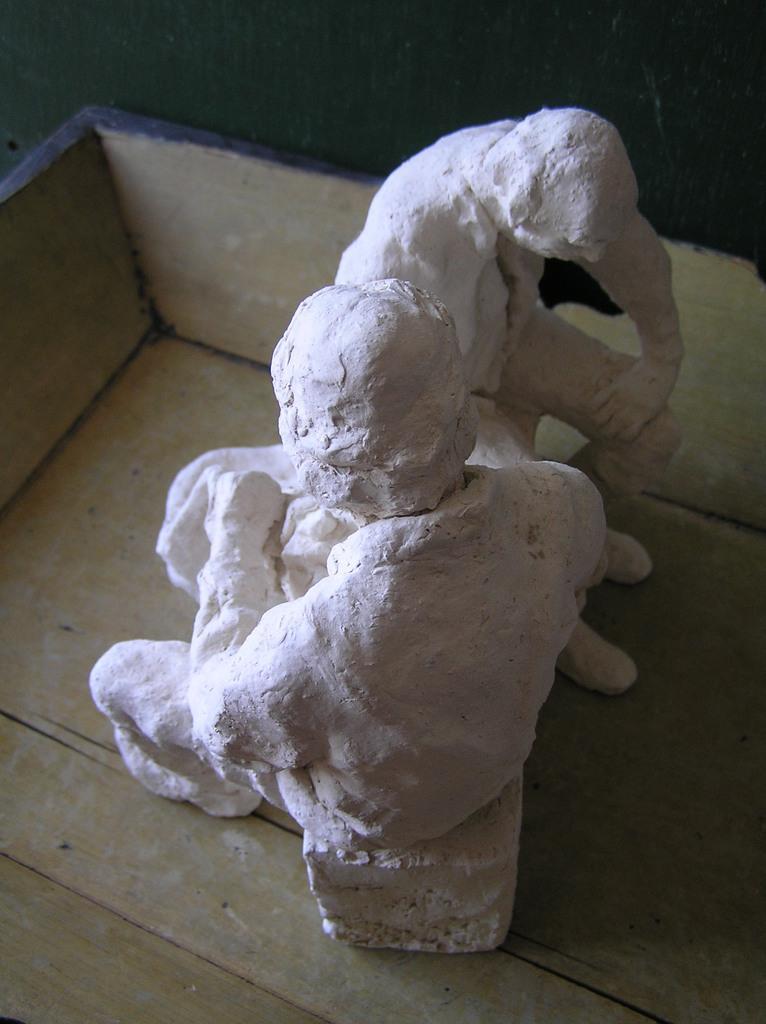Can you describe this image briefly? This pictures seems to be clicked inside. In the center we can see the two sculptures of persons seems to be sitting on the objects and the sculptures are placed in the wooden box. 